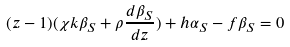Convert formula to latex. <formula><loc_0><loc_0><loc_500><loc_500>( z - 1 ) ( \chi k \beta _ { S } + \rho \frac { d \beta _ { S } } { d z } ) + h \alpha _ { S } - f \beta _ { S } = 0</formula> 